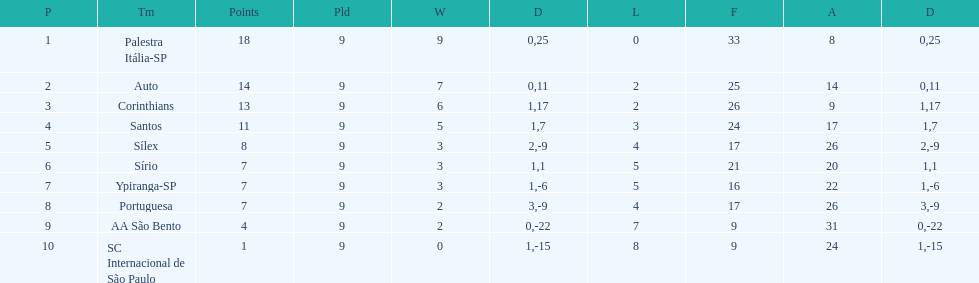In 1926 brazilian football,what was the total number of points scored? 90. 